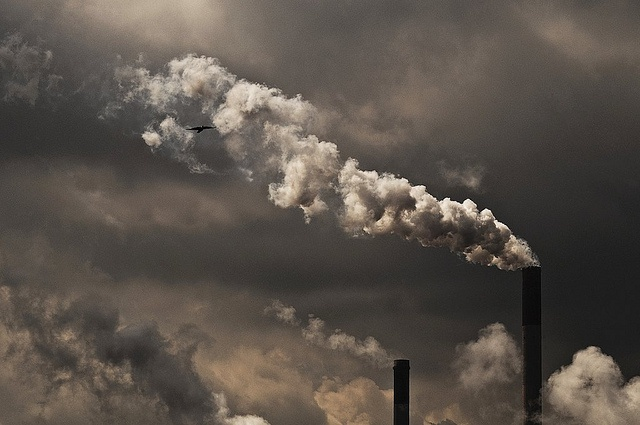Describe the objects in this image and their specific colors. I can see a bird in gray and black tones in this image. 